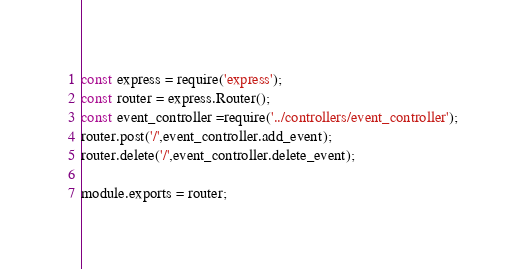<code> <loc_0><loc_0><loc_500><loc_500><_JavaScript_>const express = require('express');
const router = express.Router();
const event_controller =require('../controllers/event_controller');
router.post('/',event_controller.add_event);
router.delete('/',event_controller.delete_event);

module.exports = router;
</code> 